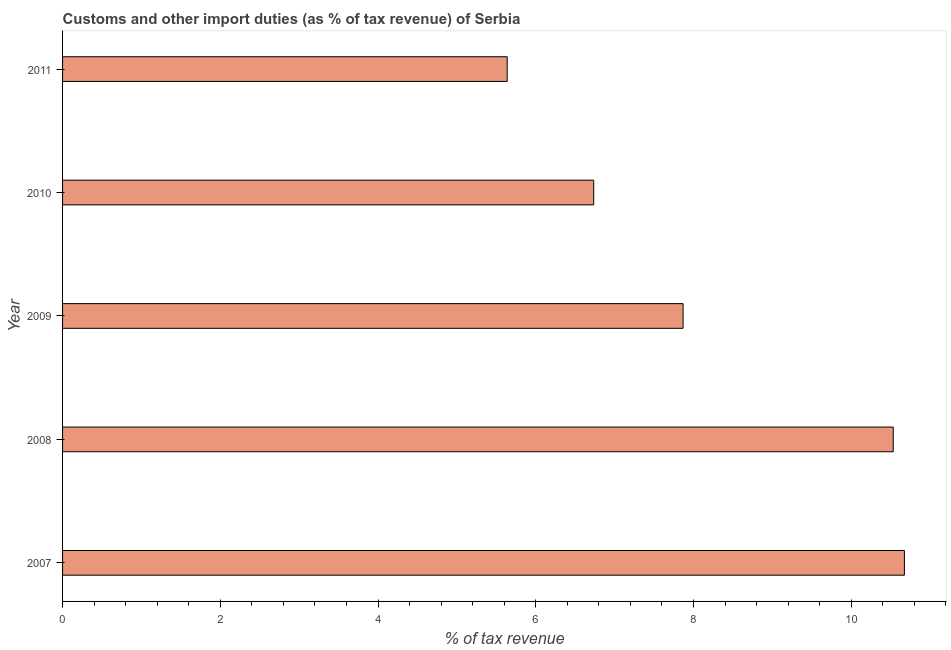Does the graph contain grids?
Offer a very short reply. No. What is the title of the graph?
Your answer should be very brief. Customs and other import duties (as % of tax revenue) of Serbia. What is the label or title of the X-axis?
Provide a succinct answer. % of tax revenue. What is the label or title of the Y-axis?
Keep it short and to the point. Year. What is the customs and other import duties in 2007?
Your answer should be compact. 10.67. Across all years, what is the maximum customs and other import duties?
Provide a succinct answer. 10.67. Across all years, what is the minimum customs and other import duties?
Make the answer very short. 5.64. In which year was the customs and other import duties maximum?
Give a very brief answer. 2007. In which year was the customs and other import duties minimum?
Ensure brevity in your answer.  2011. What is the sum of the customs and other import duties?
Keep it short and to the point. 41.45. What is the difference between the customs and other import duties in 2007 and 2011?
Give a very brief answer. 5.04. What is the average customs and other import duties per year?
Ensure brevity in your answer.  8.29. What is the median customs and other import duties?
Give a very brief answer. 7.87. In how many years, is the customs and other import duties greater than 0.8 %?
Make the answer very short. 5. What is the ratio of the customs and other import duties in 2007 to that in 2011?
Offer a terse response. 1.89. Is the difference between the customs and other import duties in 2009 and 2011 greater than the difference between any two years?
Make the answer very short. No. What is the difference between the highest and the second highest customs and other import duties?
Make the answer very short. 0.14. What is the difference between the highest and the lowest customs and other import duties?
Your response must be concise. 5.04. In how many years, is the customs and other import duties greater than the average customs and other import duties taken over all years?
Ensure brevity in your answer.  2. What is the difference between two consecutive major ticks on the X-axis?
Give a very brief answer. 2. Are the values on the major ticks of X-axis written in scientific E-notation?
Make the answer very short. No. What is the % of tax revenue in 2007?
Your answer should be very brief. 10.67. What is the % of tax revenue of 2008?
Give a very brief answer. 10.53. What is the % of tax revenue of 2009?
Your response must be concise. 7.87. What is the % of tax revenue of 2010?
Keep it short and to the point. 6.73. What is the % of tax revenue of 2011?
Offer a very short reply. 5.64. What is the difference between the % of tax revenue in 2007 and 2008?
Offer a very short reply. 0.14. What is the difference between the % of tax revenue in 2007 and 2009?
Provide a succinct answer. 2.81. What is the difference between the % of tax revenue in 2007 and 2010?
Offer a very short reply. 3.94. What is the difference between the % of tax revenue in 2007 and 2011?
Ensure brevity in your answer.  5.04. What is the difference between the % of tax revenue in 2008 and 2009?
Keep it short and to the point. 2.66. What is the difference between the % of tax revenue in 2008 and 2010?
Offer a terse response. 3.8. What is the difference between the % of tax revenue in 2008 and 2011?
Your answer should be very brief. 4.9. What is the difference between the % of tax revenue in 2009 and 2010?
Ensure brevity in your answer.  1.13. What is the difference between the % of tax revenue in 2009 and 2011?
Ensure brevity in your answer.  2.23. What is the difference between the % of tax revenue in 2010 and 2011?
Your response must be concise. 1.1. What is the ratio of the % of tax revenue in 2007 to that in 2009?
Provide a short and direct response. 1.36. What is the ratio of the % of tax revenue in 2007 to that in 2010?
Your response must be concise. 1.58. What is the ratio of the % of tax revenue in 2007 to that in 2011?
Offer a terse response. 1.89. What is the ratio of the % of tax revenue in 2008 to that in 2009?
Your response must be concise. 1.34. What is the ratio of the % of tax revenue in 2008 to that in 2010?
Ensure brevity in your answer.  1.56. What is the ratio of the % of tax revenue in 2008 to that in 2011?
Your response must be concise. 1.87. What is the ratio of the % of tax revenue in 2009 to that in 2010?
Keep it short and to the point. 1.17. What is the ratio of the % of tax revenue in 2009 to that in 2011?
Offer a very short reply. 1.4. What is the ratio of the % of tax revenue in 2010 to that in 2011?
Provide a succinct answer. 1.2. 